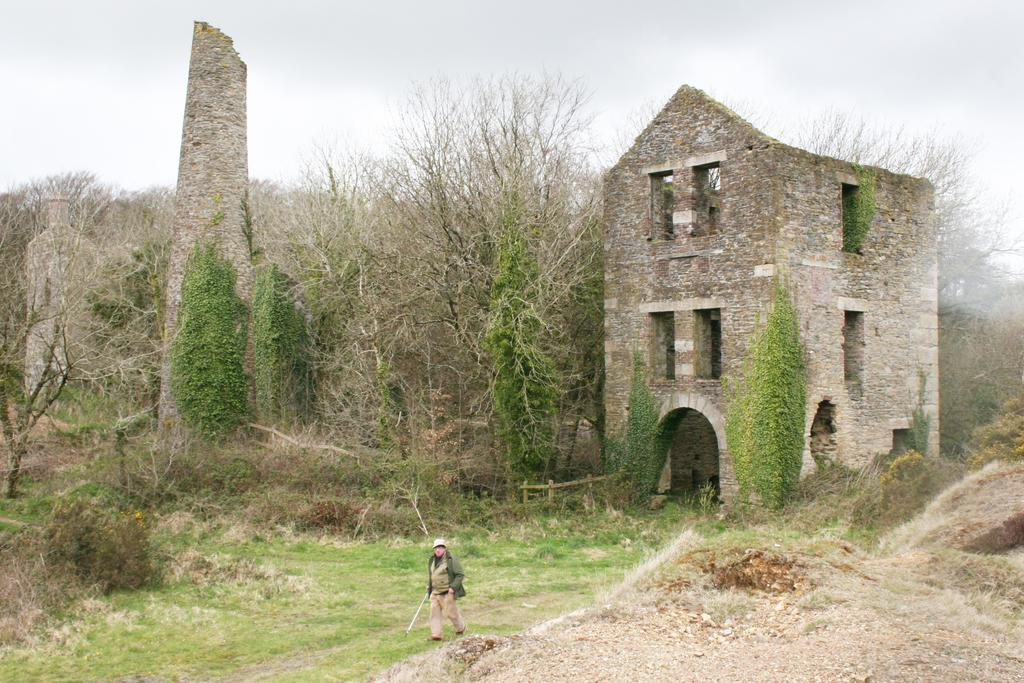What type of structure is visible in the image? There is a fort in the image. What is the person in the image doing? The person is walking in the image. What is the person holding while walking? The person is holding a stick. What type of vegetation can be seen in the image? There are trees and plants in the image. What is the condition of the sky in the image? The sky is cloudy in the image. What type of stomach ache is the writer experiencing in the image? There is no writer or stomach ache mentioned in the image; it features a fort, a person walking with a stick, trees, plants, and a cloudy sky. 